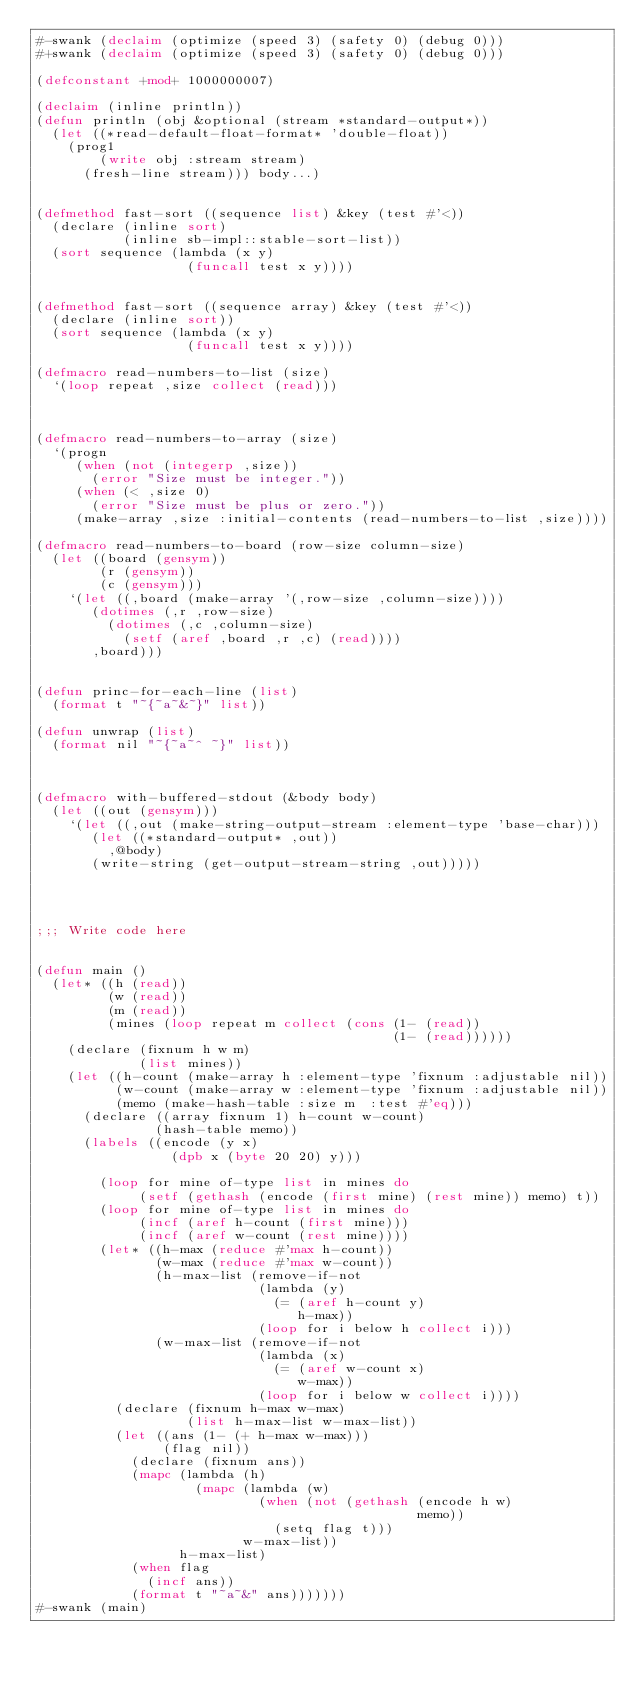Convert code to text. <code><loc_0><loc_0><loc_500><loc_500><_Lisp_>#-swank (declaim (optimize (speed 3) (safety 0) (debug 0)))
#+swank (declaim (optimize (speed 3) (safety 0) (debug 0)))

(defconstant +mod+ 1000000007)

(declaim (inline println))
(defun println (obj &optional (stream *standard-output*))
  (let ((*read-default-float-format* 'double-float))
    (prog1
        (write obj :stream stream)
      (fresh-line stream))) body...)


(defmethod fast-sort ((sequence list) &key (test #'<))
  (declare (inline sort)
           (inline sb-impl::stable-sort-list))
  (sort sequence (lambda (x y)
                   (funcall test x y))))


(defmethod fast-sort ((sequence array) &key (test #'<))
  (declare (inline sort))
  (sort sequence (lambda (x y)
                   (funcall test x y))))

(defmacro read-numbers-to-list (size)
  `(loop repeat ,size collect (read)))



(defmacro read-numbers-to-array (size)
  `(progn
     (when (not (integerp ,size))
       (error "Size must be integer."))
     (when (< ,size 0)
       (error "Size must be plus or zero."))
     (make-array ,size :initial-contents (read-numbers-to-list ,size))))

(defmacro read-numbers-to-board (row-size column-size)
  (let ((board (gensym))
        (r (gensym))
        (c (gensym)))
    `(let ((,board (make-array '(,row-size ,column-size))))
       (dotimes (,r ,row-size)
         (dotimes (,c ,column-size)
           (setf (aref ,board ,r ,c) (read))))
       ,board)))


(defun princ-for-each-line (list)
  (format t "~{~a~&~}" list))

(defun unwrap (list)
  (format nil "~{~a~^ ~}" list))



(defmacro with-buffered-stdout (&body body)
  (let ((out (gensym)))
    `(let ((,out (make-string-output-stream :element-type 'base-char)))
       (let ((*standard-output* ,out))
         ,@body)
       (write-string (get-output-stream-string ,out)))))




;;; Write code here


(defun main ()
  (let* ((h (read))
         (w (read))
         (m (read))
         (mines (loop repeat m collect (cons (1- (read))
                                             (1- (read))))))
    (declare (fixnum h w m)
             (list mines))
    (let ((h-count (make-array h :element-type 'fixnum :adjustable nil))
          (w-count (make-array w :element-type 'fixnum :adjustable nil))
          (memo (make-hash-table :size m  :test #'eq)))
      (declare ((array fixnum 1) h-count w-count)
               (hash-table memo))
      (labels ((encode (y x)
                 (dpb x (byte 20 20) y)))

        (loop for mine of-type list in mines do
             (setf (gethash (encode (first mine) (rest mine)) memo) t))
        (loop for mine of-type list in mines do
             (incf (aref h-count (first mine)))
             (incf (aref w-count (rest mine))))
        (let* ((h-max (reduce #'max h-count))
               (w-max (reduce #'max w-count))
               (h-max-list (remove-if-not
                            (lambda (y)
                              (= (aref h-count y)
                                 h-max))
                            (loop for i below h collect i)))
               (w-max-list (remove-if-not
                            (lambda (x)
                              (= (aref w-count x)
                                 w-max))
                            (loop for i below w collect i))))
          (declare (fixnum h-max w-max)
                   (list h-max-list w-max-list))
          (let ((ans (1- (+ h-max w-max)))
                (flag nil))
            (declare (fixnum ans))
            (mapc (lambda (h)
                    (mapc (lambda (w)
                            (when (not (gethash (encode h w)
                                                memo))
                              (setq flag t)))
                          w-max-list))
                  h-max-list)
            (when flag
              (incf ans))
            (format t "~a~&" ans)))))))
#-swank (main)
</code> 